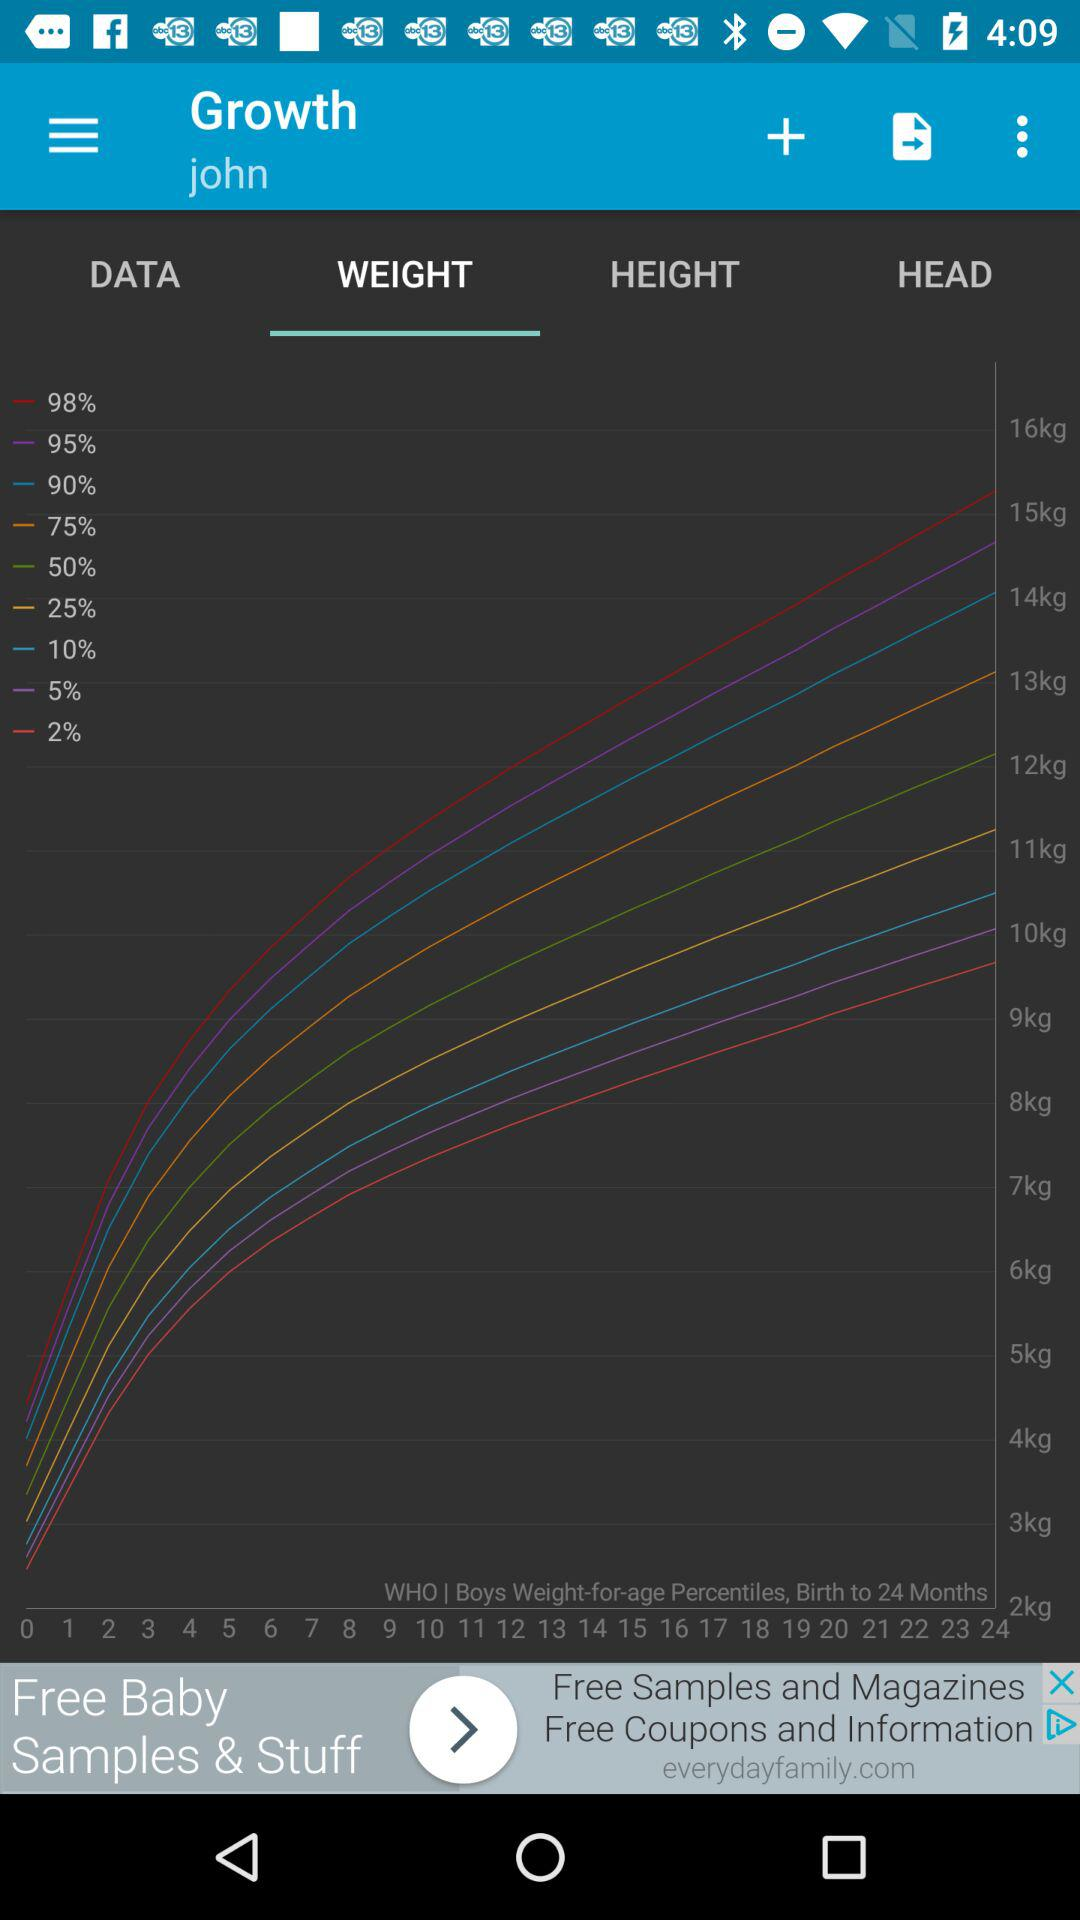Which option is selected? The selected option is "WEIGHT". 